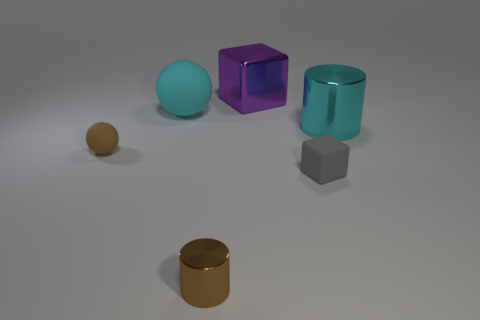Add 2 large matte spheres. How many objects exist? 8 Subtract all cylinders. How many objects are left? 4 Subtract all gray things. Subtract all tiny gray matte objects. How many objects are left? 4 Add 5 shiny objects. How many shiny objects are left? 8 Add 3 gray things. How many gray things exist? 4 Subtract 1 purple cubes. How many objects are left? 5 